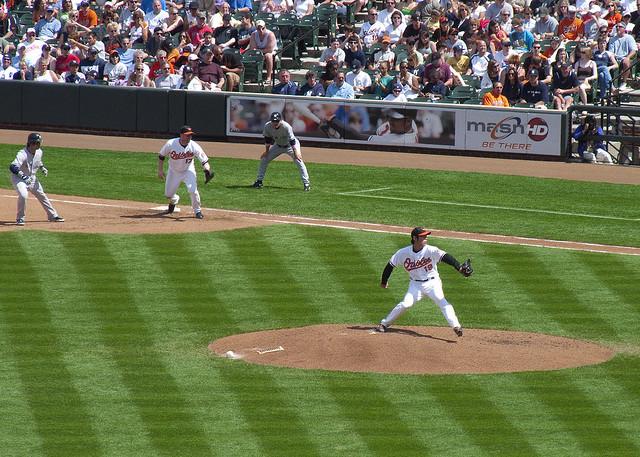What team does the pitcher play for?
Be succinct. Orioles. What is the base running coach doing?
Keep it brief. Watching. What game is being played?
Write a very short answer. Baseball. 